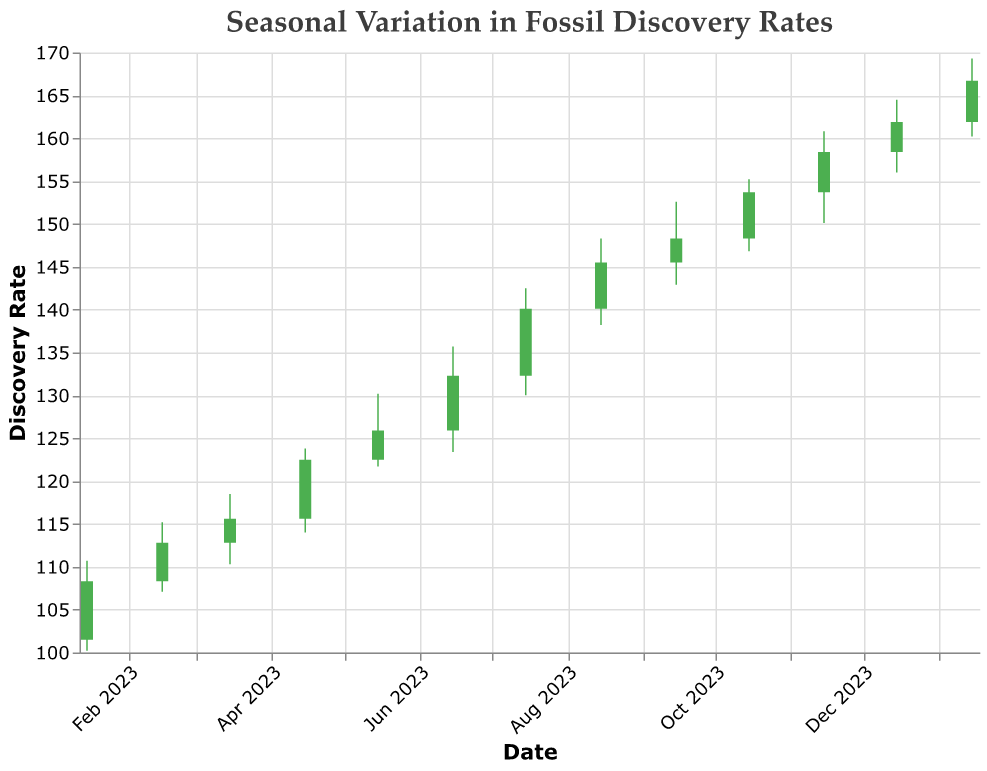How does the closing price change from January 2023 to February 2023? The closing price in January 2023 is 108.3, while in February 2023 it is 112.8. This indicates an increase.
Answer: Increase What's the highest closing price observed? The highest closing price can be found by scanning the close prices over time. The highest observed is 166.7 in January 2024.
Answer: 166.7 In which month is the largest trading volume observed? By comparing the volumes across all months, we see that the highest volume is in June 2023 with a value of 530.
Answer: June 2023 What was the closing price in August 2023? Locate August 2023 on the x-axis and observe the closing price, which is 145.5.
Answer: 145.5 How much did the closing price change from June 2023 to July 2023? The closing price in June 2023 is 132.3, and in July 2023 it is 140.1. The difference is 140.1 - 132.3 = 7.8.
Answer: 7.8 Which month saw the largest increase in closing price from the previous month? Calculate the difference in closing prices between consecutive months. The largest increase is from January 2023 (108.3) to February 2023 (112.8), a difference of 4.5.
Answer: February 2023 What is the average closing price from January 2023 to December 2023? Sum the closing prices from January 2023 to December 2023: (108.3 + 112.8 + 115.6 + 122.5 + 125.9 + 132.3 + 140.1 + 145.5 + 148.3 + 153.7 + 158.4 + 161.9) = 1675.3. Divide by 12 to get the average: 1675.3 / 12 = 139.6.
Answer: 139.6 What's the lowest low price recorded? The lowest low price can be found by examining the 'Low_Price' of each month. The lowest is 100.2 in January 2023.
Answer: 100.2 In which months did the open price exceed the close price? Inspect each month and compare the open prices with the close prices. The months where the open price exceeds the close price are April 2023, July 2023, and December 2023.
Answer: April 2023, July 2023, December 2023 